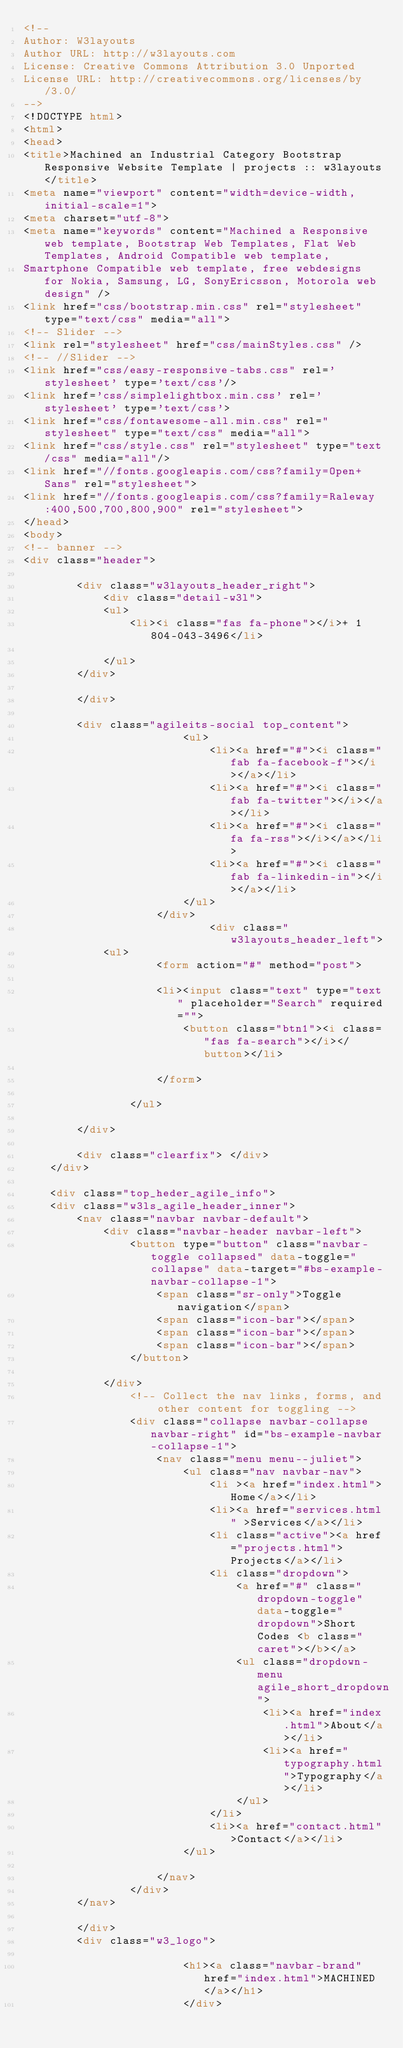Convert code to text. <code><loc_0><loc_0><loc_500><loc_500><_HTML_><!--
Author: W3layouts
Author URL: http://w3layouts.com
License: Creative Commons Attribution 3.0 Unported
License URL: http://creativecommons.org/licenses/by/3.0/
-->
<!DOCTYPE html>
<html>
<head>
<title>Machined an Industrial Category Bootstrap Responsive Website Template | projects :: w3layouts</title>
<meta name="viewport" content="width=device-width, initial-scale=1">
<meta charset="utf-8">
<meta name="keywords" content="Machined a Responsive web template, Bootstrap Web Templates, Flat Web Templates, Android Compatible web template, 
Smartphone Compatible web template, free webdesigns for Nokia, Samsung, LG, SonyEricsson, Motorola web design" />
<link href="css/bootstrap.min.css" rel="stylesheet" type="text/css" media="all">
<!-- Slider -->
<link rel="stylesheet" href="css/mainStyles.css" />
<!-- //Slider -->
<link href="css/easy-responsive-tabs.css" rel='stylesheet' type='text/css'/>
<link href='css/simplelightbox.min.css' rel='stylesheet' type='text/css'> 
<link href="css/fontawesome-all.min.css" rel="stylesheet" type="text/css" media="all">
<link href="css/style.css" rel="stylesheet" type="text/css" media="all"/>
<link href="//fonts.googleapis.com/css?family=Open+Sans" rel="stylesheet">
<link href="//fonts.googleapis.com/css?family=Raleway:400,500,700,800,900" rel="stylesheet">
</head>
<body>
<!-- banner -->
<div class="header">
		
		<div class="w3layouts_header_right">
			<div class="detail-w3l">
			<ul>
				<li><i class="fas fa-phone"></i>+ 1 804-043-3496</li>
				
			</ul>
		</div>

		</div>

		<div class="agileits-social top_content">
						<ul>
							<li><a href="#"><i class="fab fa-facebook-f"></i></a></li>
							<li><a href="#"><i class="fab fa-twitter"></i></a></li>
							<li><a href="#"><i class="fa fa-rss"></i></a></li>
							<li><a href="#"><i class="fab fa-linkedin-in"></i></a></li>
						</ul>
					</div>
							<div class="w3layouts_header_left">
			<ul>
					<form action="#" method="post">
					
					<li><input class="text" type="text" placeholder="Search" required="">
						<button class="btn1"><i class="fas fa-search"></i></button></li>
					
					</form>
					
				</ul>

		</div>

		<div class="clearfix"> </div>
	</div>

	<div class="top_heder_agile_info">
	<div class="w3ls_agile_header_inner">	
		<nav class="navbar navbar-default">
			<div class="navbar-header navbar-left">
				<button type="button" class="navbar-toggle collapsed" data-toggle="collapse" data-target="#bs-example-navbar-collapse-1">
					<span class="sr-only">Toggle navigation</span>
					<span class="icon-bar"></span>
					<span class="icon-bar"></span>
					<span class="icon-bar"></span>
				</button>
				
			</div>
				<!-- Collect the nav links, forms, and other content for toggling -->
				<div class="collapse navbar-collapse navbar-right" id="bs-example-navbar-collapse-1">
					<nav class="menu menu--juliet">
						<ul class="nav navbar-nav">
							<li ><a href="index.html">Home</a></li>
							<li><a href="services.html" >Services</a></li>
							<li class="active"><a href="projects.html">Projects</a></li>
							<li class="dropdown">
								<a href="#" class="dropdown-toggle" data-toggle="dropdown">Short Codes <b class="caret"></b></a>
								<ul class="dropdown-menu agile_short_dropdown">
									<li><a href="index.html">About</a></li>
									<li><a href="typography.html">Typography</a></li>
								</ul>
							</li>
							<li><a href="contact.html">Contact</a></li>
						</ul>
						
					</nav>
				</div>
		</nav>
		
		</div>
		<div class="w3_logo">
						
						<h1><a class="navbar-brand" href="index.html">MACHINED</a></h1>
						</div></code> 